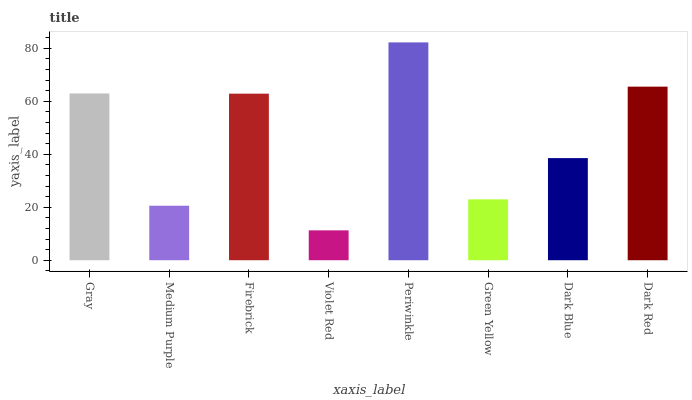Is Violet Red the minimum?
Answer yes or no. Yes. Is Periwinkle the maximum?
Answer yes or no. Yes. Is Medium Purple the minimum?
Answer yes or no. No. Is Medium Purple the maximum?
Answer yes or no. No. Is Gray greater than Medium Purple?
Answer yes or no. Yes. Is Medium Purple less than Gray?
Answer yes or no. Yes. Is Medium Purple greater than Gray?
Answer yes or no. No. Is Gray less than Medium Purple?
Answer yes or no. No. Is Firebrick the high median?
Answer yes or no. Yes. Is Dark Blue the low median?
Answer yes or no. Yes. Is Green Yellow the high median?
Answer yes or no. No. Is Violet Red the low median?
Answer yes or no. No. 